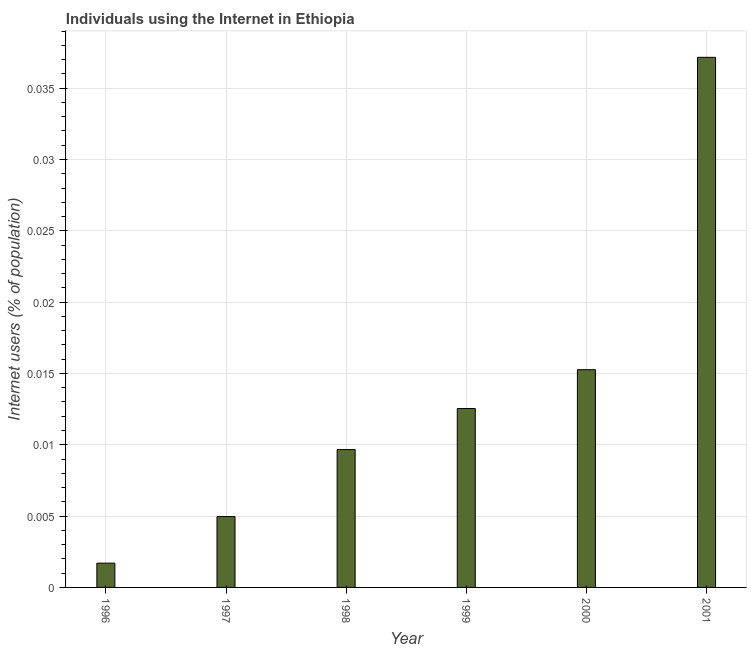What is the title of the graph?
Make the answer very short. Individuals using the Internet in Ethiopia. What is the label or title of the Y-axis?
Offer a terse response. Internet users (% of population). What is the number of internet users in 2000?
Provide a short and direct response. 0.02. Across all years, what is the maximum number of internet users?
Provide a short and direct response. 0.04. Across all years, what is the minimum number of internet users?
Provide a short and direct response. 0. In which year was the number of internet users minimum?
Provide a short and direct response. 1996. What is the sum of the number of internet users?
Keep it short and to the point. 0.08. What is the difference between the number of internet users in 1997 and 1998?
Your answer should be compact. -0.01. What is the average number of internet users per year?
Keep it short and to the point. 0.01. What is the median number of internet users?
Ensure brevity in your answer.  0.01. In how many years, is the number of internet users greater than 0.029 %?
Give a very brief answer. 1. What is the ratio of the number of internet users in 1996 to that in 2000?
Your response must be concise. 0.11. Is the number of internet users in 1999 less than that in 2001?
Keep it short and to the point. Yes. Is the difference between the number of internet users in 1996 and 2001 greater than the difference between any two years?
Make the answer very short. Yes. What is the difference between the highest and the second highest number of internet users?
Provide a succinct answer. 0.02. Is the sum of the number of internet users in 1998 and 2000 greater than the maximum number of internet users across all years?
Give a very brief answer. No. What is the difference between the highest and the lowest number of internet users?
Your response must be concise. 0.04. In how many years, is the number of internet users greater than the average number of internet users taken over all years?
Provide a short and direct response. 2. What is the difference between two consecutive major ticks on the Y-axis?
Your response must be concise. 0.01. Are the values on the major ticks of Y-axis written in scientific E-notation?
Your response must be concise. No. What is the Internet users (% of population) of 1996?
Make the answer very short. 0. What is the Internet users (% of population) in 1997?
Provide a succinct answer. 0. What is the Internet users (% of population) of 1998?
Give a very brief answer. 0.01. What is the Internet users (% of population) of 1999?
Give a very brief answer. 0.01. What is the Internet users (% of population) of 2000?
Ensure brevity in your answer.  0.02. What is the Internet users (% of population) in 2001?
Provide a succinct answer. 0.04. What is the difference between the Internet users (% of population) in 1996 and 1997?
Give a very brief answer. -0. What is the difference between the Internet users (% of population) in 1996 and 1998?
Provide a succinct answer. -0.01. What is the difference between the Internet users (% of population) in 1996 and 1999?
Keep it short and to the point. -0.01. What is the difference between the Internet users (% of population) in 1996 and 2000?
Give a very brief answer. -0.01. What is the difference between the Internet users (% of population) in 1996 and 2001?
Your response must be concise. -0.04. What is the difference between the Internet users (% of population) in 1997 and 1998?
Ensure brevity in your answer.  -0. What is the difference between the Internet users (% of population) in 1997 and 1999?
Keep it short and to the point. -0.01. What is the difference between the Internet users (% of population) in 1997 and 2000?
Keep it short and to the point. -0.01. What is the difference between the Internet users (% of population) in 1997 and 2001?
Your answer should be very brief. -0.03. What is the difference between the Internet users (% of population) in 1998 and 1999?
Provide a succinct answer. -0. What is the difference between the Internet users (% of population) in 1998 and 2000?
Provide a short and direct response. -0.01. What is the difference between the Internet users (% of population) in 1998 and 2001?
Your response must be concise. -0.03. What is the difference between the Internet users (% of population) in 1999 and 2000?
Keep it short and to the point. -0. What is the difference between the Internet users (% of population) in 1999 and 2001?
Keep it short and to the point. -0.02. What is the difference between the Internet users (% of population) in 2000 and 2001?
Provide a short and direct response. -0.02. What is the ratio of the Internet users (% of population) in 1996 to that in 1997?
Your response must be concise. 0.34. What is the ratio of the Internet users (% of population) in 1996 to that in 1998?
Give a very brief answer. 0.18. What is the ratio of the Internet users (% of population) in 1996 to that in 1999?
Make the answer very short. 0.14. What is the ratio of the Internet users (% of population) in 1996 to that in 2000?
Your response must be concise. 0.11. What is the ratio of the Internet users (% of population) in 1996 to that in 2001?
Provide a succinct answer. 0.05. What is the ratio of the Internet users (% of population) in 1997 to that in 1998?
Offer a terse response. 0.51. What is the ratio of the Internet users (% of population) in 1997 to that in 1999?
Provide a succinct answer. 0.4. What is the ratio of the Internet users (% of population) in 1997 to that in 2000?
Keep it short and to the point. 0.33. What is the ratio of the Internet users (% of population) in 1997 to that in 2001?
Provide a succinct answer. 0.13. What is the ratio of the Internet users (% of population) in 1998 to that in 1999?
Give a very brief answer. 0.77. What is the ratio of the Internet users (% of population) in 1998 to that in 2000?
Keep it short and to the point. 0.63. What is the ratio of the Internet users (% of population) in 1998 to that in 2001?
Offer a terse response. 0.26. What is the ratio of the Internet users (% of population) in 1999 to that in 2000?
Your answer should be very brief. 0.82. What is the ratio of the Internet users (% of population) in 1999 to that in 2001?
Your response must be concise. 0.34. What is the ratio of the Internet users (% of population) in 2000 to that in 2001?
Give a very brief answer. 0.41. 